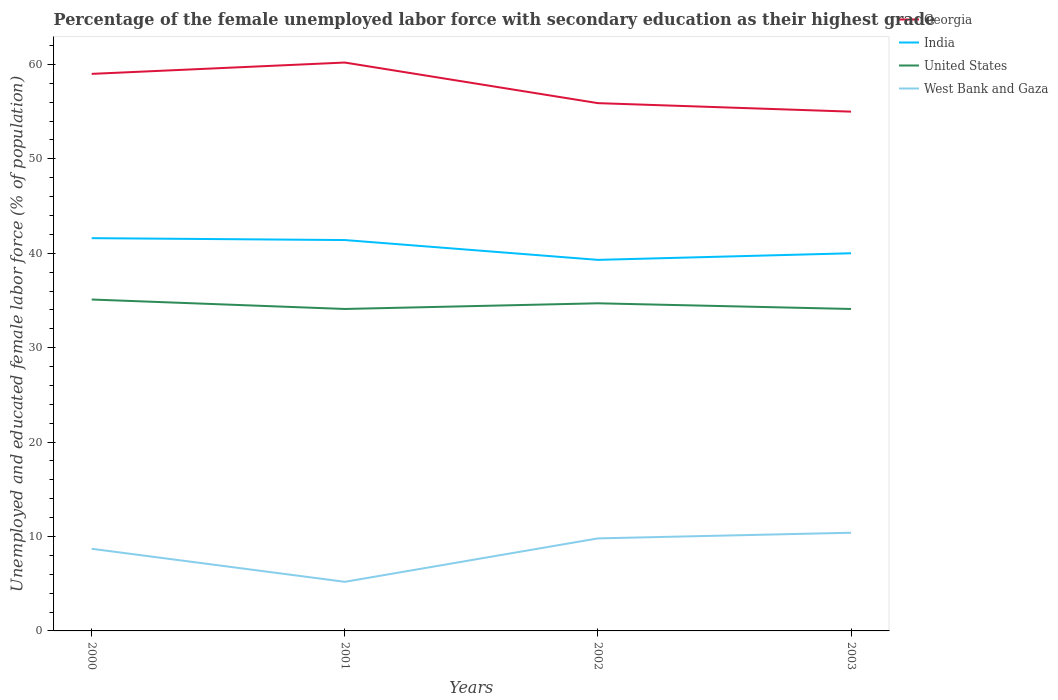Does the line corresponding to West Bank and Gaza intersect with the line corresponding to United States?
Your answer should be compact. No. Across all years, what is the maximum percentage of the unemployed female labor force with secondary education in India?
Provide a short and direct response. 39.3. In which year was the percentage of the unemployed female labor force with secondary education in India maximum?
Make the answer very short. 2002. What is the total percentage of the unemployed female labor force with secondary education in India in the graph?
Offer a terse response. 2.3. What is the difference between the highest and the second highest percentage of the unemployed female labor force with secondary education in Georgia?
Give a very brief answer. 5.2. Is the percentage of the unemployed female labor force with secondary education in India strictly greater than the percentage of the unemployed female labor force with secondary education in Georgia over the years?
Your answer should be very brief. Yes. How many lines are there?
Make the answer very short. 4. How many years are there in the graph?
Your response must be concise. 4. What is the difference between two consecutive major ticks on the Y-axis?
Give a very brief answer. 10. Does the graph contain any zero values?
Your answer should be compact. No. Does the graph contain grids?
Make the answer very short. No. What is the title of the graph?
Keep it short and to the point. Percentage of the female unemployed labor force with secondary education as their highest grade. Does "Austria" appear as one of the legend labels in the graph?
Make the answer very short. No. What is the label or title of the Y-axis?
Your response must be concise. Unemployed and educated female labor force (% of population). What is the Unemployed and educated female labor force (% of population) of India in 2000?
Your answer should be compact. 41.6. What is the Unemployed and educated female labor force (% of population) in United States in 2000?
Your answer should be compact. 35.1. What is the Unemployed and educated female labor force (% of population) in West Bank and Gaza in 2000?
Offer a terse response. 8.7. What is the Unemployed and educated female labor force (% of population) in Georgia in 2001?
Your answer should be very brief. 60.2. What is the Unemployed and educated female labor force (% of population) of India in 2001?
Your answer should be very brief. 41.4. What is the Unemployed and educated female labor force (% of population) in United States in 2001?
Keep it short and to the point. 34.1. What is the Unemployed and educated female labor force (% of population) in West Bank and Gaza in 2001?
Your response must be concise. 5.2. What is the Unemployed and educated female labor force (% of population) of Georgia in 2002?
Provide a short and direct response. 55.9. What is the Unemployed and educated female labor force (% of population) of India in 2002?
Make the answer very short. 39.3. What is the Unemployed and educated female labor force (% of population) of United States in 2002?
Provide a succinct answer. 34.7. What is the Unemployed and educated female labor force (% of population) in West Bank and Gaza in 2002?
Give a very brief answer. 9.8. What is the Unemployed and educated female labor force (% of population) in India in 2003?
Ensure brevity in your answer.  40. What is the Unemployed and educated female labor force (% of population) in United States in 2003?
Your answer should be compact. 34.1. What is the Unemployed and educated female labor force (% of population) in West Bank and Gaza in 2003?
Provide a succinct answer. 10.4. Across all years, what is the maximum Unemployed and educated female labor force (% of population) in Georgia?
Ensure brevity in your answer.  60.2. Across all years, what is the maximum Unemployed and educated female labor force (% of population) in India?
Offer a very short reply. 41.6. Across all years, what is the maximum Unemployed and educated female labor force (% of population) in United States?
Make the answer very short. 35.1. Across all years, what is the maximum Unemployed and educated female labor force (% of population) of West Bank and Gaza?
Keep it short and to the point. 10.4. Across all years, what is the minimum Unemployed and educated female labor force (% of population) in Georgia?
Your response must be concise. 55. Across all years, what is the minimum Unemployed and educated female labor force (% of population) of India?
Your answer should be very brief. 39.3. Across all years, what is the minimum Unemployed and educated female labor force (% of population) of United States?
Ensure brevity in your answer.  34.1. Across all years, what is the minimum Unemployed and educated female labor force (% of population) of West Bank and Gaza?
Provide a short and direct response. 5.2. What is the total Unemployed and educated female labor force (% of population) of Georgia in the graph?
Offer a very short reply. 230.1. What is the total Unemployed and educated female labor force (% of population) in India in the graph?
Ensure brevity in your answer.  162.3. What is the total Unemployed and educated female labor force (% of population) of United States in the graph?
Offer a terse response. 138. What is the total Unemployed and educated female labor force (% of population) of West Bank and Gaza in the graph?
Offer a terse response. 34.1. What is the difference between the Unemployed and educated female labor force (% of population) of Georgia in 2000 and that in 2001?
Make the answer very short. -1.2. What is the difference between the Unemployed and educated female labor force (% of population) in United States in 2000 and that in 2001?
Your answer should be compact. 1. What is the difference between the Unemployed and educated female labor force (% of population) of West Bank and Gaza in 2000 and that in 2001?
Ensure brevity in your answer.  3.5. What is the difference between the Unemployed and educated female labor force (% of population) in Georgia in 2000 and that in 2002?
Your answer should be very brief. 3.1. What is the difference between the Unemployed and educated female labor force (% of population) of India in 2000 and that in 2002?
Make the answer very short. 2.3. What is the difference between the Unemployed and educated female labor force (% of population) of West Bank and Gaza in 2000 and that in 2002?
Your answer should be compact. -1.1. What is the difference between the Unemployed and educated female labor force (% of population) of Georgia in 2000 and that in 2003?
Keep it short and to the point. 4. What is the difference between the Unemployed and educated female labor force (% of population) of India in 2000 and that in 2003?
Make the answer very short. 1.6. What is the difference between the Unemployed and educated female labor force (% of population) of India in 2001 and that in 2002?
Your answer should be compact. 2.1. What is the difference between the Unemployed and educated female labor force (% of population) in United States in 2001 and that in 2002?
Keep it short and to the point. -0.6. What is the difference between the Unemployed and educated female labor force (% of population) of West Bank and Gaza in 2001 and that in 2002?
Offer a very short reply. -4.6. What is the difference between the Unemployed and educated female labor force (% of population) of West Bank and Gaza in 2001 and that in 2003?
Your answer should be compact. -5.2. What is the difference between the Unemployed and educated female labor force (% of population) of Georgia in 2002 and that in 2003?
Offer a very short reply. 0.9. What is the difference between the Unemployed and educated female labor force (% of population) in India in 2002 and that in 2003?
Your response must be concise. -0.7. What is the difference between the Unemployed and educated female labor force (% of population) of United States in 2002 and that in 2003?
Your response must be concise. 0.6. What is the difference between the Unemployed and educated female labor force (% of population) in West Bank and Gaza in 2002 and that in 2003?
Give a very brief answer. -0.6. What is the difference between the Unemployed and educated female labor force (% of population) in Georgia in 2000 and the Unemployed and educated female labor force (% of population) in United States in 2001?
Make the answer very short. 24.9. What is the difference between the Unemployed and educated female labor force (% of population) in Georgia in 2000 and the Unemployed and educated female labor force (% of population) in West Bank and Gaza in 2001?
Provide a short and direct response. 53.8. What is the difference between the Unemployed and educated female labor force (% of population) in India in 2000 and the Unemployed and educated female labor force (% of population) in United States in 2001?
Provide a succinct answer. 7.5. What is the difference between the Unemployed and educated female labor force (% of population) in India in 2000 and the Unemployed and educated female labor force (% of population) in West Bank and Gaza in 2001?
Your answer should be very brief. 36.4. What is the difference between the Unemployed and educated female labor force (% of population) of United States in 2000 and the Unemployed and educated female labor force (% of population) of West Bank and Gaza in 2001?
Your answer should be very brief. 29.9. What is the difference between the Unemployed and educated female labor force (% of population) in Georgia in 2000 and the Unemployed and educated female labor force (% of population) in United States in 2002?
Provide a short and direct response. 24.3. What is the difference between the Unemployed and educated female labor force (% of population) in Georgia in 2000 and the Unemployed and educated female labor force (% of population) in West Bank and Gaza in 2002?
Provide a short and direct response. 49.2. What is the difference between the Unemployed and educated female labor force (% of population) of India in 2000 and the Unemployed and educated female labor force (% of population) of United States in 2002?
Your answer should be very brief. 6.9. What is the difference between the Unemployed and educated female labor force (% of population) of India in 2000 and the Unemployed and educated female labor force (% of population) of West Bank and Gaza in 2002?
Give a very brief answer. 31.8. What is the difference between the Unemployed and educated female labor force (% of population) of United States in 2000 and the Unemployed and educated female labor force (% of population) of West Bank and Gaza in 2002?
Provide a succinct answer. 25.3. What is the difference between the Unemployed and educated female labor force (% of population) of Georgia in 2000 and the Unemployed and educated female labor force (% of population) of India in 2003?
Ensure brevity in your answer.  19. What is the difference between the Unemployed and educated female labor force (% of population) of Georgia in 2000 and the Unemployed and educated female labor force (% of population) of United States in 2003?
Offer a very short reply. 24.9. What is the difference between the Unemployed and educated female labor force (% of population) of Georgia in 2000 and the Unemployed and educated female labor force (% of population) of West Bank and Gaza in 2003?
Make the answer very short. 48.6. What is the difference between the Unemployed and educated female labor force (% of population) of India in 2000 and the Unemployed and educated female labor force (% of population) of West Bank and Gaza in 2003?
Your answer should be very brief. 31.2. What is the difference between the Unemployed and educated female labor force (% of population) in United States in 2000 and the Unemployed and educated female labor force (% of population) in West Bank and Gaza in 2003?
Make the answer very short. 24.7. What is the difference between the Unemployed and educated female labor force (% of population) in Georgia in 2001 and the Unemployed and educated female labor force (% of population) in India in 2002?
Your answer should be compact. 20.9. What is the difference between the Unemployed and educated female labor force (% of population) in Georgia in 2001 and the Unemployed and educated female labor force (% of population) in United States in 2002?
Offer a very short reply. 25.5. What is the difference between the Unemployed and educated female labor force (% of population) of Georgia in 2001 and the Unemployed and educated female labor force (% of population) of West Bank and Gaza in 2002?
Offer a terse response. 50.4. What is the difference between the Unemployed and educated female labor force (% of population) in India in 2001 and the Unemployed and educated female labor force (% of population) in West Bank and Gaza in 2002?
Provide a succinct answer. 31.6. What is the difference between the Unemployed and educated female labor force (% of population) in United States in 2001 and the Unemployed and educated female labor force (% of population) in West Bank and Gaza in 2002?
Give a very brief answer. 24.3. What is the difference between the Unemployed and educated female labor force (% of population) in Georgia in 2001 and the Unemployed and educated female labor force (% of population) in India in 2003?
Your answer should be compact. 20.2. What is the difference between the Unemployed and educated female labor force (% of population) in Georgia in 2001 and the Unemployed and educated female labor force (% of population) in United States in 2003?
Keep it short and to the point. 26.1. What is the difference between the Unemployed and educated female labor force (% of population) in Georgia in 2001 and the Unemployed and educated female labor force (% of population) in West Bank and Gaza in 2003?
Your answer should be very brief. 49.8. What is the difference between the Unemployed and educated female labor force (% of population) in India in 2001 and the Unemployed and educated female labor force (% of population) in United States in 2003?
Give a very brief answer. 7.3. What is the difference between the Unemployed and educated female labor force (% of population) in United States in 2001 and the Unemployed and educated female labor force (% of population) in West Bank and Gaza in 2003?
Make the answer very short. 23.7. What is the difference between the Unemployed and educated female labor force (% of population) of Georgia in 2002 and the Unemployed and educated female labor force (% of population) of India in 2003?
Make the answer very short. 15.9. What is the difference between the Unemployed and educated female labor force (% of population) of Georgia in 2002 and the Unemployed and educated female labor force (% of population) of United States in 2003?
Give a very brief answer. 21.8. What is the difference between the Unemployed and educated female labor force (% of population) in Georgia in 2002 and the Unemployed and educated female labor force (% of population) in West Bank and Gaza in 2003?
Offer a very short reply. 45.5. What is the difference between the Unemployed and educated female labor force (% of population) in India in 2002 and the Unemployed and educated female labor force (% of population) in United States in 2003?
Offer a very short reply. 5.2. What is the difference between the Unemployed and educated female labor force (% of population) in India in 2002 and the Unemployed and educated female labor force (% of population) in West Bank and Gaza in 2003?
Your answer should be very brief. 28.9. What is the difference between the Unemployed and educated female labor force (% of population) in United States in 2002 and the Unemployed and educated female labor force (% of population) in West Bank and Gaza in 2003?
Make the answer very short. 24.3. What is the average Unemployed and educated female labor force (% of population) in Georgia per year?
Make the answer very short. 57.52. What is the average Unemployed and educated female labor force (% of population) of India per year?
Ensure brevity in your answer.  40.58. What is the average Unemployed and educated female labor force (% of population) in United States per year?
Provide a succinct answer. 34.5. What is the average Unemployed and educated female labor force (% of population) of West Bank and Gaza per year?
Ensure brevity in your answer.  8.53. In the year 2000, what is the difference between the Unemployed and educated female labor force (% of population) of Georgia and Unemployed and educated female labor force (% of population) of India?
Keep it short and to the point. 17.4. In the year 2000, what is the difference between the Unemployed and educated female labor force (% of population) in Georgia and Unemployed and educated female labor force (% of population) in United States?
Offer a terse response. 23.9. In the year 2000, what is the difference between the Unemployed and educated female labor force (% of population) of Georgia and Unemployed and educated female labor force (% of population) of West Bank and Gaza?
Keep it short and to the point. 50.3. In the year 2000, what is the difference between the Unemployed and educated female labor force (% of population) in India and Unemployed and educated female labor force (% of population) in United States?
Give a very brief answer. 6.5. In the year 2000, what is the difference between the Unemployed and educated female labor force (% of population) of India and Unemployed and educated female labor force (% of population) of West Bank and Gaza?
Provide a succinct answer. 32.9. In the year 2000, what is the difference between the Unemployed and educated female labor force (% of population) of United States and Unemployed and educated female labor force (% of population) of West Bank and Gaza?
Give a very brief answer. 26.4. In the year 2001, what is the difference between the Unemployed and educated female labor force (% of population) in Georgia and Unemployed and educated female labor force (% of population) in United States?
Provide a succinct answer. 26.1. In the year 2001, what is the difference between the Unemployed and educated female labor force (% of population) in India and Unemployed and educated female labor force (% of population) in United States?
Your response must be concise. 7.3. In the year 2001, what is the difference between the Unemployed and educated female labor force (% of population) in India and Unemployed and educated female labor force (% of population) in West Bank and Gaza?
Provide a succinct answer. 36.2. In the year 2001, what is the difference between the Unemployed and educated female labor force (% of population) in United States and Unemployed and educated female labor force (% of population) in West Bank and Gaza?
Your answer should be very brief. 28.9. In the year 2002, what is the difference between the Unemployed and educated female labor force (% of population) in Georgia and Unemployed and educated female labor force (% of population) in India?
Your response must be concise. 16.6. In the year 2002, what is the difference between the Unemployed and educated female labor force (% of population) in Georgia and Unemployed and educated female labor force (% of population) in United States?
Provide a short and direct response. 21.2. In the year 2002, what is the difference between the Unemployed and educated female labor force (% of population) in Georgia and Unemployed and educated female labor force (% of population) in West Bank and Gaza?
Offer a terse response. 46.1. In the year 2002, what is the difference between the Unemployed and educated female labor force (% of population) in India and Unemployed and educated female labor force (% of population) in United States?
Your answer should be compact. 4.6. In the year 2002, what is the difference between the Unemployed and educated female labor force (% of population) of India and Unemployed and educated female labor force (% of population) of West Bank and Gaza?
Your answer should be very brief. 29.5. In the year 2002, what is the difference between the Unemployed and educated female labor force (% of population) of United States and Unemployed and educated female labor force (% of population) of West Bank and Gaza?
Your answer should be very brief. 24.9. In the year 2003, what is the difference between the Unemployed and educated female labor force (% of population) of Georgia and Unemployed and educated female labor force (% of population) of United States?
Ensure brevity in your answer.  20.9. In the year 2003, what is the difference between the Unemployed and educated female labor force (% of population) of Georgia and Unemployed and educated female labor force (% of population) of West Bank and Gaza?
Your response must be concise. 44.6. In the year 2003, what is the difference between the Unemployed and educated female labor force (% of population) in India and Unemployed and educated female labor force (% of population) in United States?
Offer a very short reply. 5.9. In the year 2003, what is the difference between the Unemployed and educated female labor force (% of population) in India and Unemployed and educated female labor force (% of population) in West Bank and Gaza?
Give a very brief answer. 29.6. In the year 2003, what is the difference between the Unemployed and educated female labor force (% of population) of United States and Unemployed and educated female labor force (% of population) of West Bank and Gaza?
Provide a succinct answer. 23.7. What is the ratio of the Unemployed and educated female labor force (% of population) in Georgia in 2000 to that in 2001?
Ensure brevity in your answer.  0.98. What is the ratio of the Unemployed and educated female labor force (% of population) of India in 2000 to that in 2001?
Your answer should be very brief. 1. What is the ratio of the Unemployed and educated female labor force (% of population) in United States in 2000 to that in 2001?
Provide a short and direct response. 1.03. What is the ratio of the Unemployed and educated female labor force (% of population) of West Bank and Gaza in 2000 to that in 2001?
Give a very brief answer. 1.67. What is the ratio of the Unemployed and educated female labor force (% of population) in Georgia in 2000 to that in 2002?
Ensure brevity in your answer.  1.06. What is the ratio of the Unemployed and educated female labor force (% of population) of India in 2000 to that in 2002?
Make the answer very short. 1.06. What is the ratio of the Unemployed and educated female labor force (% of population) of United States in 2000 to that in 2002?
Offer a very short reply. 1.01. What is the ratio of the Unemployed and educated female labor force (% of population) in West Bank and Gaza in 2000 to that in 2002?
Make the answer very short. 0.89. What is the ratio of the Unemployed and educated female labor force (% of population) of Georgia in 2000 to that in 2003?
Your answer should be compact. 1.07. What is the ratio of the Unemployed and educated female labor force (% of population) in United States in 2000 to that in 2003?
Offer a terse response. 1.03. What is the ratio of the Unemployed and educated female labor force (% of population) in West Bank and Gaza in 2000 to that in 2003?
Your answer should be compact. 0.84. What is the ratio of the Unemployed and educated female labor force (% of population) of Georgia in 2001 to that in 2002?
Your answer should be very brief. 1.08. What is the ratio of the Unemployed and educated female labor force (% of population) in India in 2001 to that in 2002?
Give a very brief answer. 1.05. What is the ratio of the Unemployed and educated female labor force (% of population) of United States in 2001 to that in 2002?
Offer a very short reply. 0.98. What is the ratio of the Unemployed and educated female labor force (% of population) of West Bank and Gaza in 2001 to that in 2002?
Your answer should be very brief. 0.53. What is the ratio of the Unemployed and educated female labor force (% of population) of Georgia in 2001 to that in 2003?
Give a very brief answer. 1.09. What is the ratio of the Unemployed and educated female labor force (% of population) in India in 2001 to that in 2003?
Your response must be concise. 1.03. What is the ratio of the Unemployed and educated female labor force (% of population) of West Bank and Gaza in 2001 to that in 2003?
Give a very brief answer. 0.5. What is the ratio of the Unemployed and educated female labor force (% of population) of Georgia in 2002 to that in 2003?
Your response must be concise. 1.02. What is the ratio of the Unemployed and educated female labor force (% of population) of India in 2002 to that in 2003?
Ensure brevity in your answer.  0.98. What is the ratio of the Unemployed and educated female labor force (% of population) of United States in 2002 to that in 2003?
Ensure brevity in your answer.  1.02. What is the ratio of the Unemployed and educated female labor force (% of population) in West Bank and Gaza in 2002 to that in 2003?
Give a very brief answer. 0.94. 